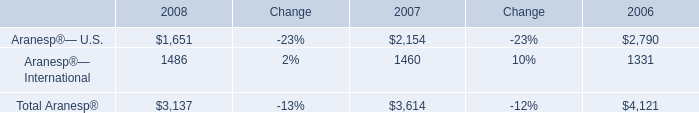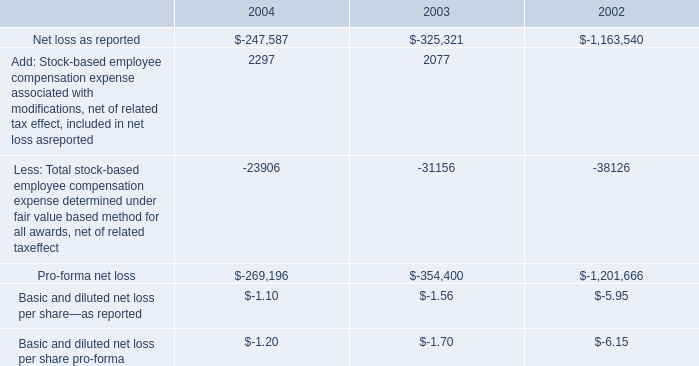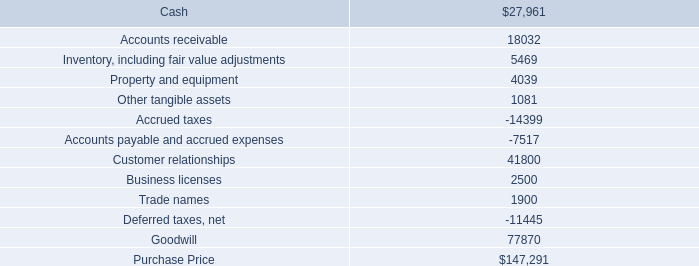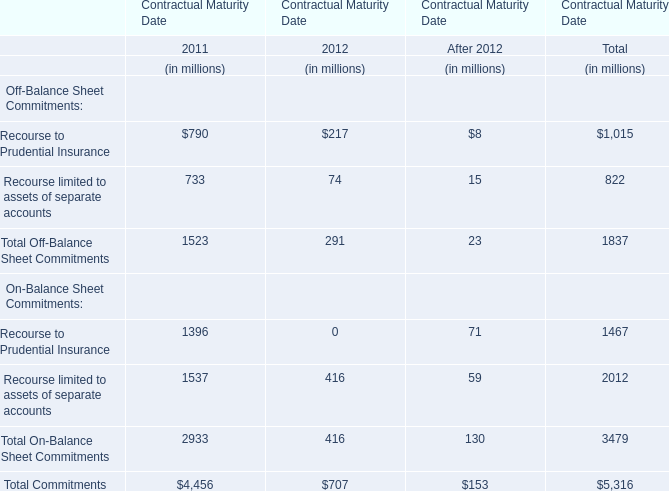what is the percentage change in 401 ( k ) contributed amounts from 2002 to 2003? 
Computations: ((825000 - 979000) / 979000)
Answer: -0.1573. 